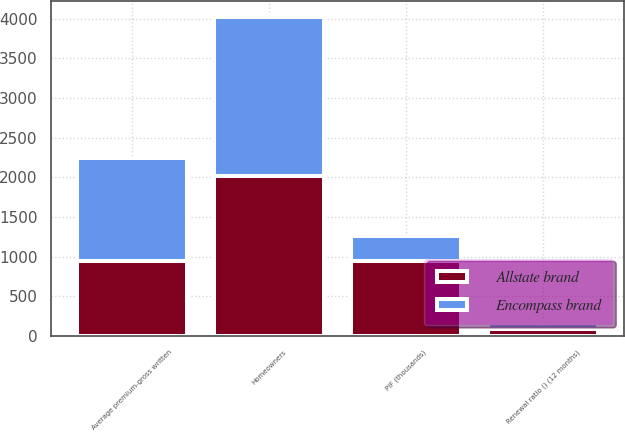<chart> <loc_0><loc_0><loc_500><loc_500><stacked_bar_chart><ecel><fcel>Homeowners<fcel>PIF (thousands)<fcel>Average premium-gross written<fcel>Renewal ratio () (12 months)<nl><fcel>Allstate brand<fcel>2010<fcel>943<fcel>943<fcel>88.4<nl><fcel>Encompass brand<fcel>2010<fcel>314<fcel>1298<fcel>78.1<nl></chart> 